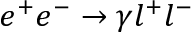Convert formula to latex. <formula><loc_0><loc_0><loc_500><loc_500>e ^ { + } e ^ { - } \rightarrow \gamma l ^ { + } l ^ { - }</formula> 